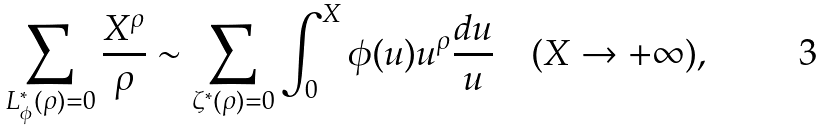<formula> <loc_0><loc_0><loc_500><loc_500>\sum _ { L _ { \phi } ^ { \ast } ( \rho ) = 0 } \frac { X ^ { \rho } } { \rho } \sim \sum _ { \zeta ^ { \ast } ( \rho ) = 0 } \int _ { 0 } ^ { X } \phi ( u ) u ^ { \rho } \frac { d u } { u } \quad ( X \to + \infty ) ,</formula> 